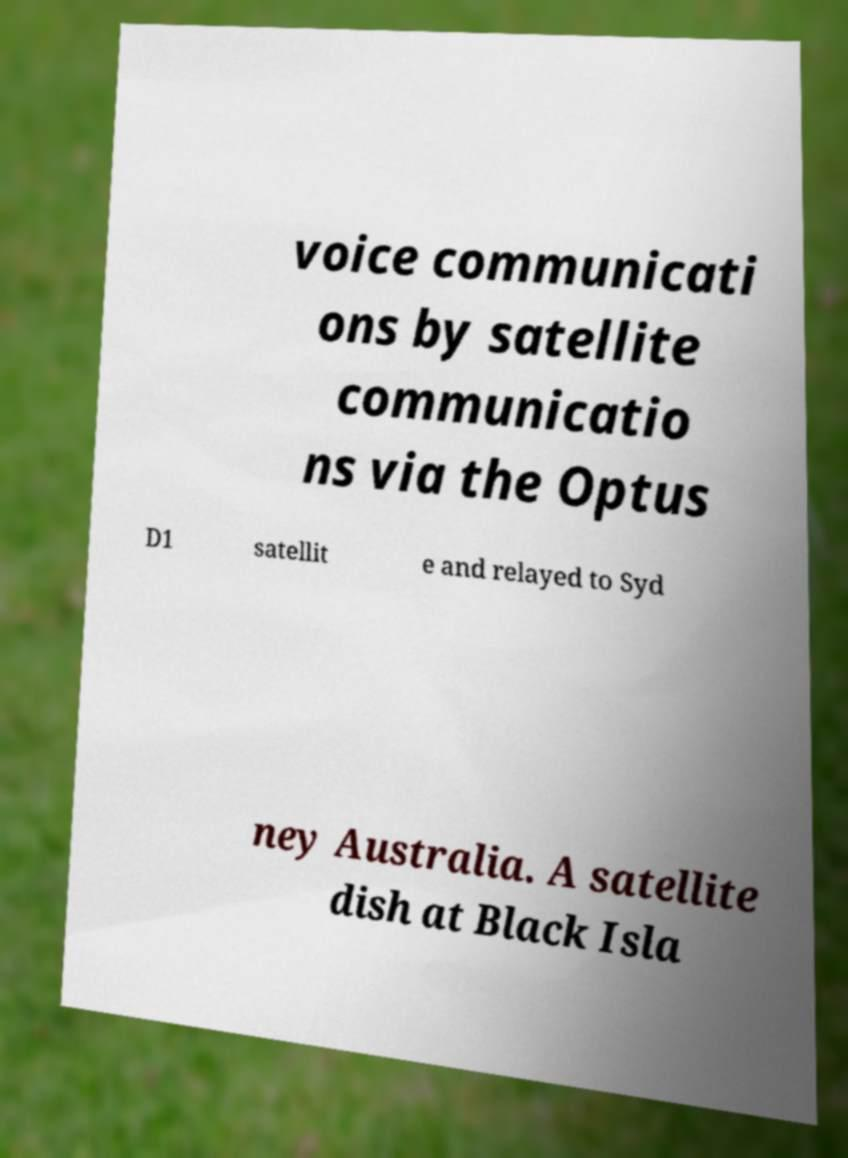There's text embedded in this image that I need extracted. Can you transcribe it verbatim? voice communicati ons by satellite communicatio ns via the Optus D1 satellit e and relayed to Syd ney Australia. A satellite dish at Black Isla 